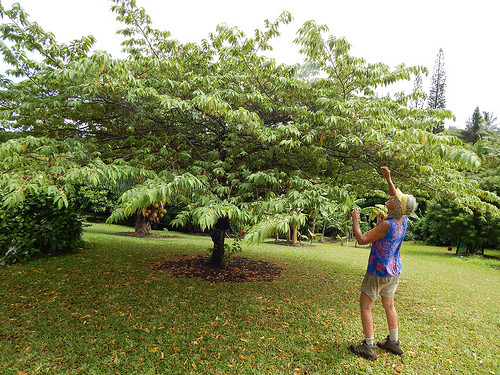<image>
Is the sky under the tree? No. The sky is not positioned under the tree. The vertical relationship between these objects is different. 